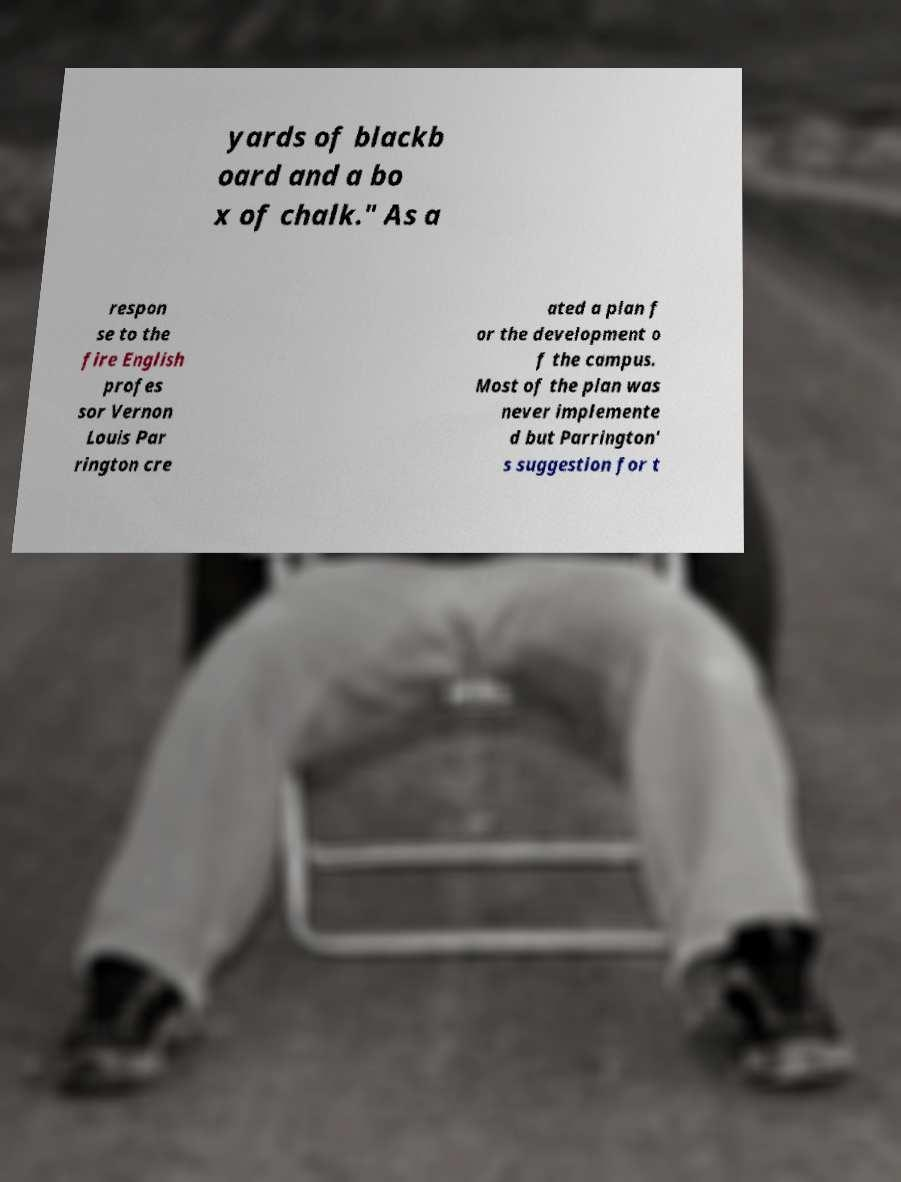What messages or text are displayed in this image? I need them in a readable, typed format. yards of blackb oard and a bo x of chalk." As a respon se to the fire English profes sor Vernon Louis Par rington cre ated a plan f or the development o f the campus. Most of the plan was never implemente d but Parrington' s suggestion for t 